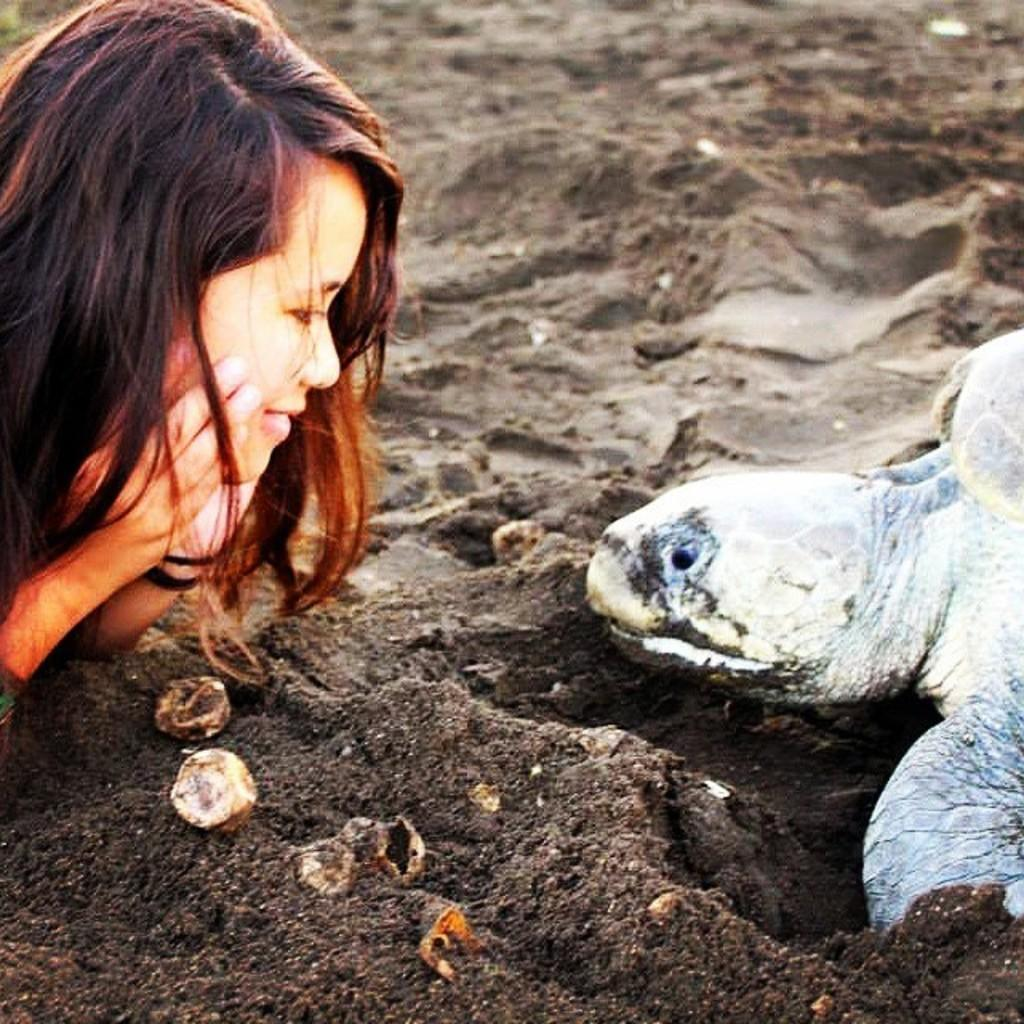Who is present in the image? There is a woman in the image. What is the woman doing in the image? The woman is smiling in the image. Where is the woman located in the image? The woman is visible on the left side of the image. What is the woman looking at in the image? The woman is looking at a tortoise in the image. Can you describe the tortoise in the image? There is a tortoise in the image, and it is visible on the right side. What type of bead is the woman using to process the hen in the image? There is no bead, processing, or hen present in the image. 